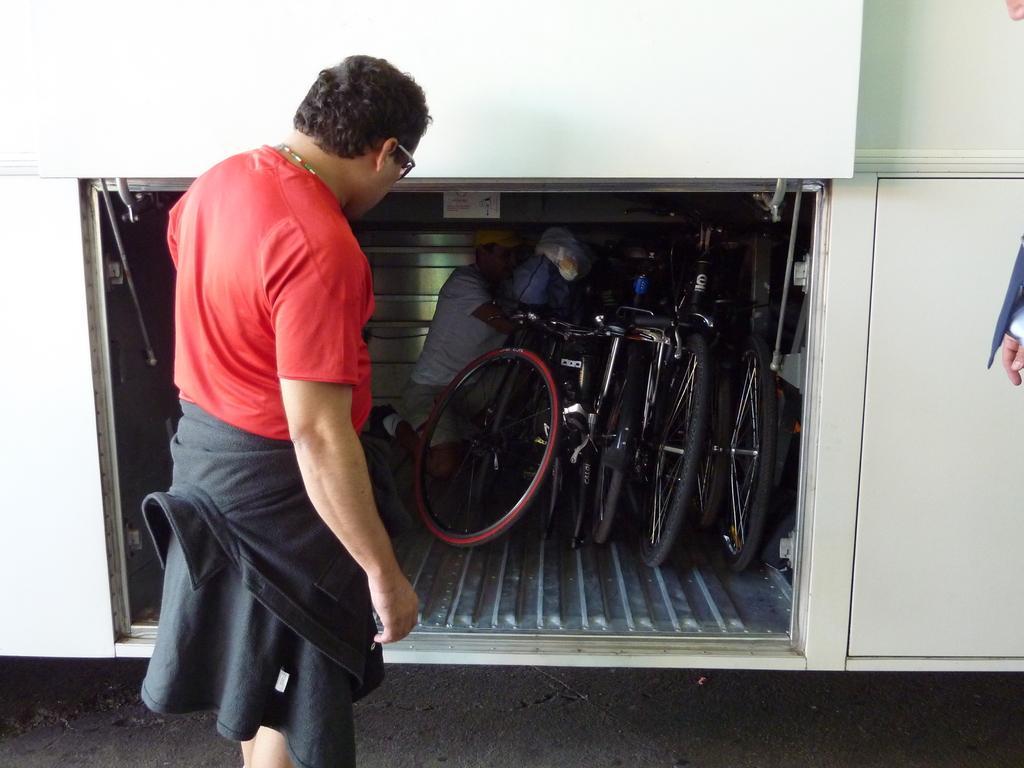Could you give a brief overview of what you see in this image? In this image there are two persons, and there are bicycles and a person inside a vehicle trunk. 